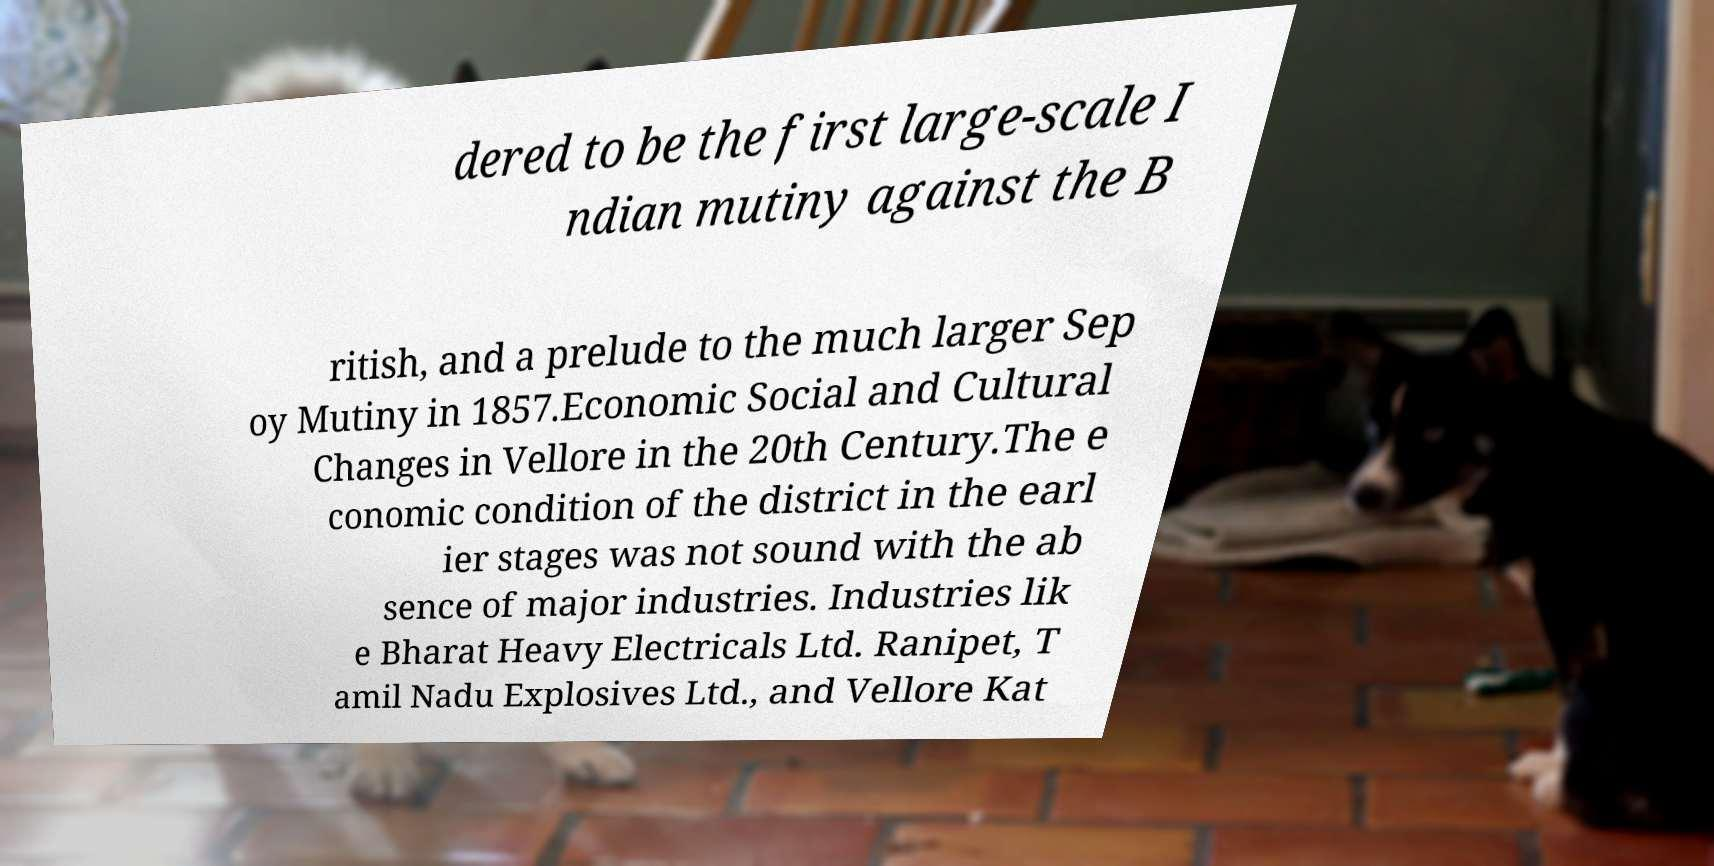Can you accurately transcribe the text from the provided image for me? dered to be the first large-scale I ndian mutiny against the B ritish, and a prelude to the much larger Sep oy Mutiny in 1857.Economic Social and Cultural Changes in Vellore in the 20th Century.The e conomic condition of the district in the earl ier stages was not sound with the ab sence of major industries. Industries lik e Bharat Heavy Electricals Ltd. Ranipet, T amil Nadu Explosives Ltd., and Vellore Kat 